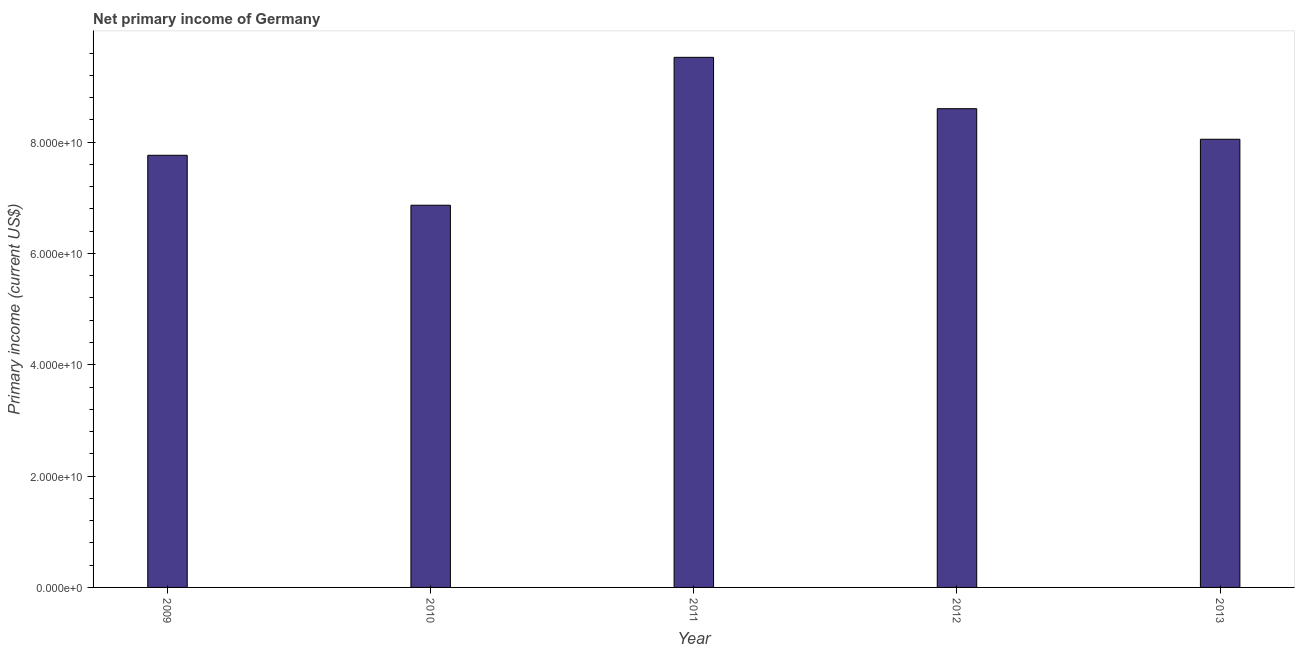Does the graph contain any zero values?
Your answer should be very brief. No. Does the graph contain grids?
Make the answer very short. No. What is the title of the graph?
Provide a succinct answer. Net primary income of Germany. What is the label or title of the Y-axis?
Provide a succinct answer. Primary income (current US$). What is the amount of primary income in 2013?
Ensure brevity in your answer.  8.05e+1. Across all years, what is the maximum amount of primary income?
Provide a succinct answer. 9.52e+1. Across all years, what is the minimum amount of primary income?
Your answer should be very brief. 6.87e+1. What is the sum of the amount of primary income?
Your answer should be compact. 4.08e+11. What is the difference between the amount of primary income in 2011 and 2013?
Keep it short and to the point. 1.47e+1. What is the average amount of primary income per year?
Your answer should be compact. 8.16e+1. What is the median amount of primary income?
Offer a very short reply. 8.05e+1. What is the ratio of the amount of primary income in 2009 to that in 2010?
Provide a short and direct response. 1.13. What is the difference between the highest and the second highest amount of primary income?
Give a very brief answer. 9.23e+09. What is the difference between the highest and the lowest amount of primary income?
Ensure brevity in your answer.  2.66e+1. In how many years, is the amount of primary income greater than the average amount of primary income taken over all years?
Offer a very short reply. 2. How many bars are there?
Make the answer very short. 5. Are all the bars in the graph horizontal?
Your answer should be compact. No. How many years are there in the graph?
Offer a very short reply. 5. Are the values on the major ticks of Y-axis written in scientific E-notation?
Make the answer very short. Yes. What is the Primary income (current US$) in 2009?
Offer a terse response. 7.76e+1. What is the Primary income (current US$) in 2010?
Offer a very short reply. 6.87e+1. What is the Primary income (current US$) of 2011?
Your answer should be compact. 9.52e+1. What is the Primary income (current US$) of 2012?
Keep it short and to the point. 8.60e+1. What is the Primary income (current US$) of 2013?
Offer a terse response. 8.05e+1. What is the difference between the Primary income (current US$) in 2009 and 2010?
Your answer should be very brief. 8.97e+09. What is the difference between the Primary income (current US$) in 2009 and 2011?
Offer a very short reply. -1.76e+1. What is the difference between the Primary income (current US$) in 2009 and 2012?
Give a very brief answer. -8.37e+09. What is the difference between the Primary income (current US$) in 2009 and 2013?
Offer a very short reply. -2.88e+09. What is the difference between the Primary income (current US$) in 2010 and 2011?
Offer a terse response. -2.66e+1. What is the difference between the Primary income (current US$) in 2010 and 2012?
Make the answer very short. -1.73e+1. What is the difference between the Primary income (current US$) in 2010 and 2013?
Your response must be concise. -1.19e+1. What is the difference between the Primary income (current US$) in 2011 and 2012?
Provide a short and direct response. 9.23e+09. What is the difference between the Primary income (current US$) in 2011 and 2013?
Offer a very short reply. 1.47e+1. What is the difference between the Primary income (current US$) in 2012 and 2013?
Give a very brief answer. 5.49e+09. What is the ratio of the Primary income (current US$) in 2009 to that in 2010?
Ensure brevity in your answer.  1.13. What is the ratio of the Primary income (current US$) in 2009 to that in 2011?
Keep it short and to the point. 0.81. What is the ratio of the Primary income (current US$) in 2009 to that in 2012?
Your answer should be very brief. 0.9. What is the ratio of the Primary income (current US$) in 2009 to that in 2013?
Keep it short and to the point. 0.96. What is the ratio of the Primary income (current US$) in 2010 to that in 2011?
Your response must be concise. 0.72. What is the ratio of the Primary income (current US$) in 2010 to that in 2012?
Your answer should be compact. 0.8. What is the ratio of the Primary income (current US$) in 2010 to that in 2013?
Make the answer very short. 0.85. What is the ratio of the Primary income (current US$) in 2011 to that in 2012?
Make the answer very short. 1.11. What is the ratio of the Primary income (current US$) in 2011 to that in 2013?
Provide a short and direct response. 1.18. What is the ratio of the Primary income (current US$) in 2012 to that in 2013?
Offer a very short reply. 1.07. 